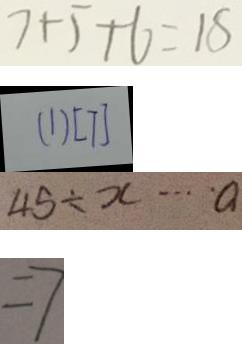<formula> <loc_0><loc_0><loc_500><loc_500>7 + 5 + 6 = 1 5 
 ( 1 ) [ 7 ] 
 4 5 \div x \cdots a 
 = 7</formula> 